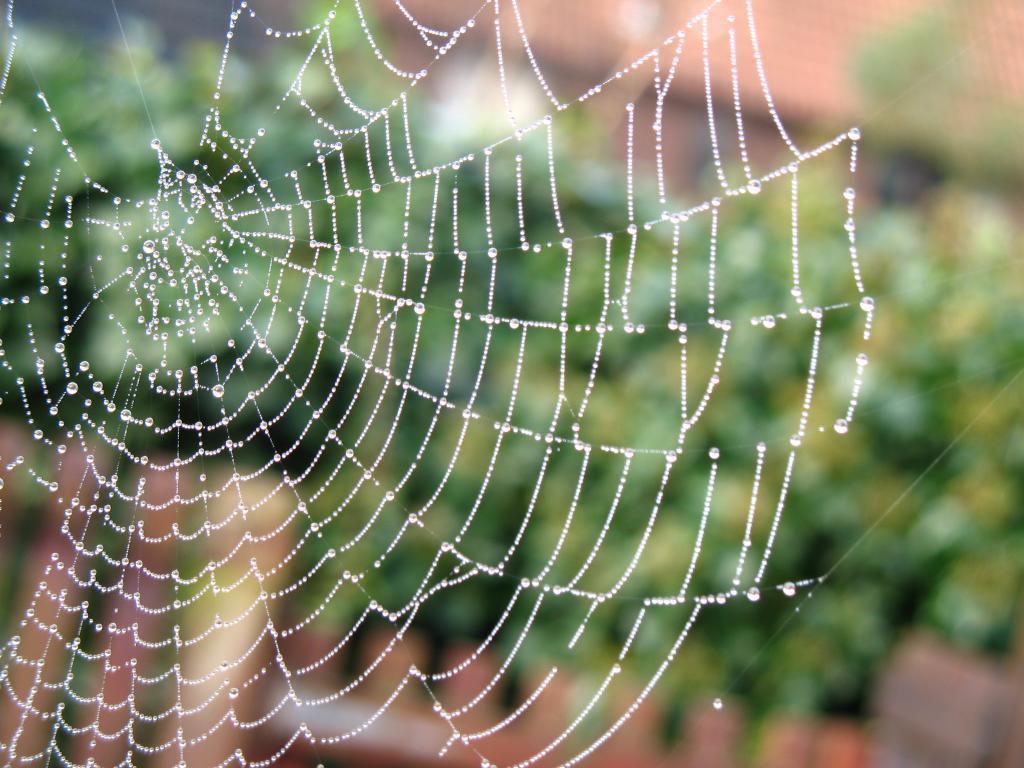Please provide a concise description of this image. In this image we can see a spider web. 